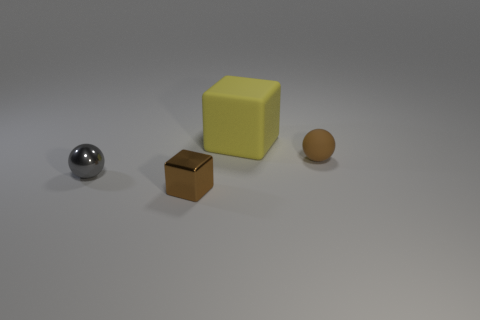Add 2 yellow matte blocks. How many objects exist? 6 Subtract 0 blue spheres. How many objects are left? 4 Subtract all matte blocks. Subtract all shiny objects. How many objects are left? 1 Add 2 small brown metal blocks. How many small brown metal blocks are left? 3 Add 4 small gray spheres. How many small gray spheres exist? 5 